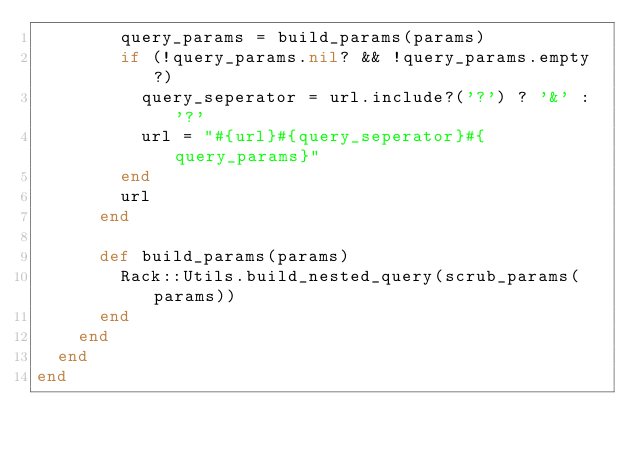Convert code to text. <code><loc_0><loc_0><loc_500><loc_500><_Ruby_>        query_params = build_params(params)
        if (!query_params.nil? && !query_params.empty?)
          query_seperator = url.include?('?') ? '&' : '?'
          url = "#{url}#{query_seperator}#{query_params}"
        end
        url
      end

      def build_params(params)
        Rack::Utils.build_nested_query(scrub_params(params))
      end
    end
  end
end
</code> 